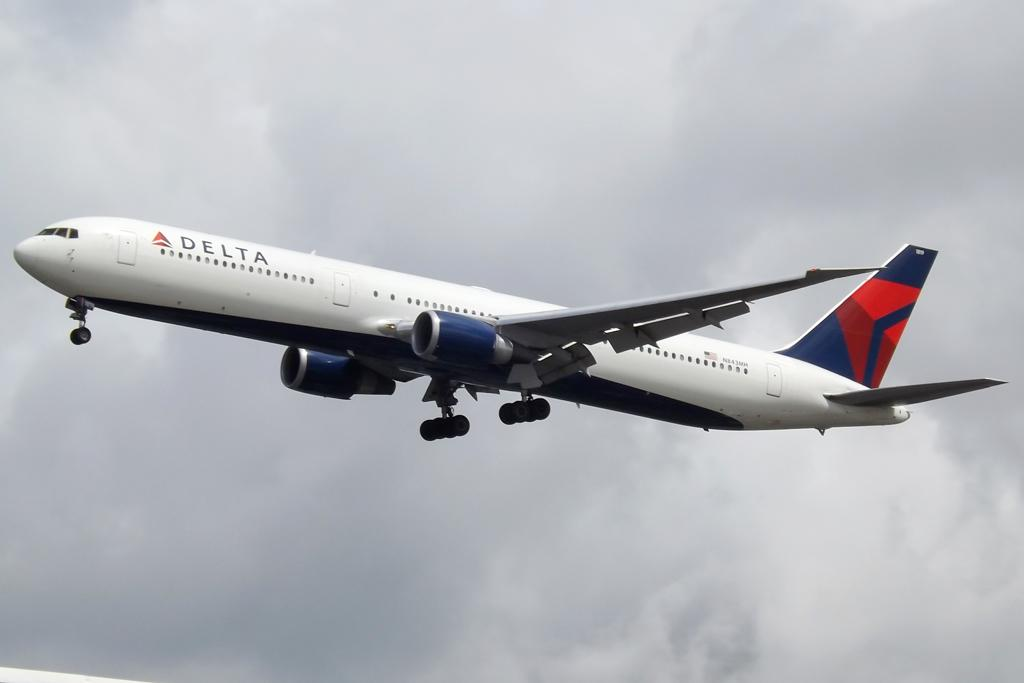What is the main subject of the picture? The main subject of the picture is an airplane. What is the airplane doing in the picture? The airplane is flying in the sky. What type of flower can be seen growing on the wing of the airplane in the image? There is no flower present on the wing of the airplane in the image. How many trays of food are being served on the airplane in the image? There is no information about trays or food being served on the airplane in the image. 